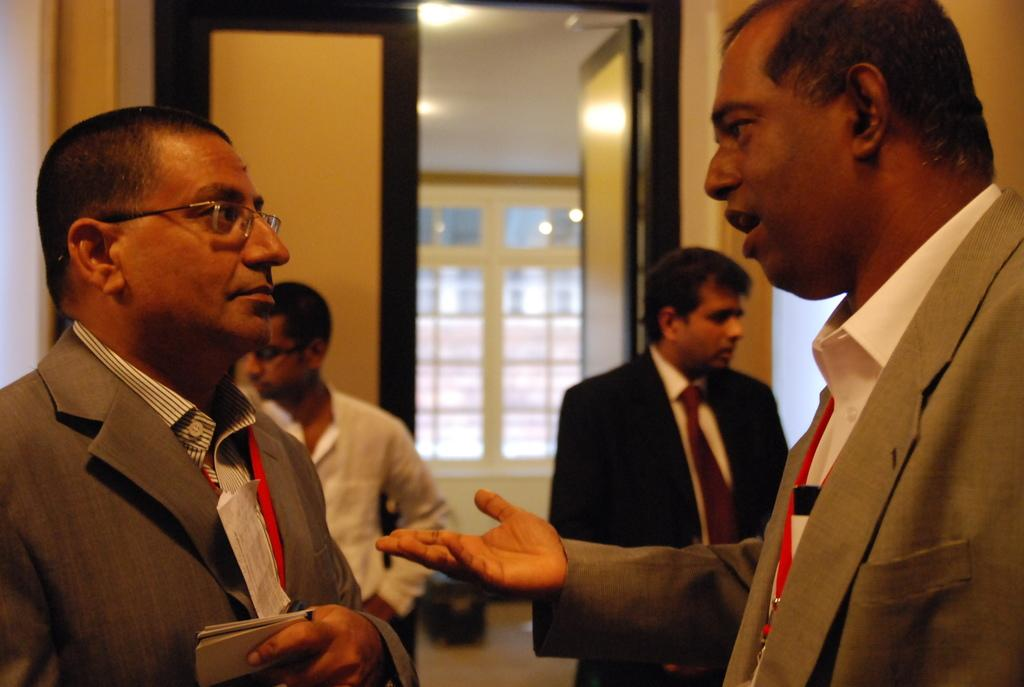Who or what can be seen in the image? There are people in the image. What are the people doing in the image? The people are standing and talking. Where is the scene taking place? The setting is inside a room. What type of tomatoes can be seen in the basin in the image? There is no basin or tomatoes present in the image. How many carts are visible in the image? There are no carts visible in the image. 